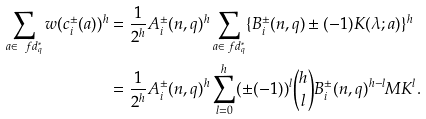<formula> <loc_0><loc_0><loc_500><loc_500>\sum _ { a \in \ f d _ { q } ^ { * } } w ( c _ { i } ^ { \pm } ( a ) ) ^ { h } & = \frac { 1 } { 2 ^ { h } } A _ { i } ^ { \pm } ( n , q ) ^ { h } \sum _ { a \in \ f d _ { q } ^ { * } } \{ B _ { i } ^ { \pm } ( n , q ) \pm ( - 1 ) K ( \lambda ; a ) \} ^ { h } \\ & = \frac { 1 } { 2 ^ { h } } A _ { i } ^ { \pm } ( n , q ) ^ { h } \sum _ { l = 0 } ^ { h } ( \pm ( - 1 ) ) ^ { l } { h \choose l } B _ { i } ^ { \pm } ( n , q ) ^ { h - l } M K ^ { l } .</formula> 